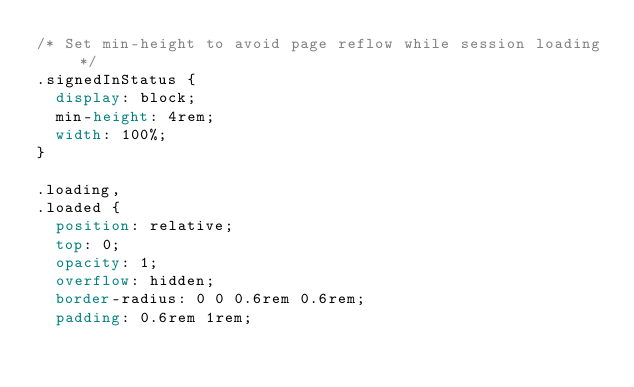Convert code to text. <code><loc_0><loc_0><loc_500><loc_500><_CSS_>/* Set min-height to avoid page reflow while session loading */
.signedInStatus {
  display: block;
  min-height: 4rem;
  width: 100%;
}

.loading,
.loaded {
  position: relative;
  top: 0;
  opacity: 1;
  overflow: hidden;
  border-radius: 0 0 0.6rem 0.6rem;
  padding: 0.6rem 1rem;</code> 